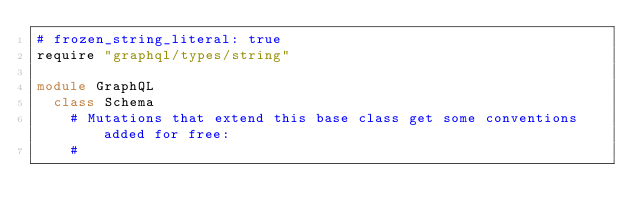Convert code to text. <code><loc_0><loc_0><loc_500><loc_500><_Ruby_># frozen_string_literal: true
require "graphql/types/string"

module GraphQL
  class Schema
    # Mutations that extend this base class get some conventions added for free:
    #</code> 